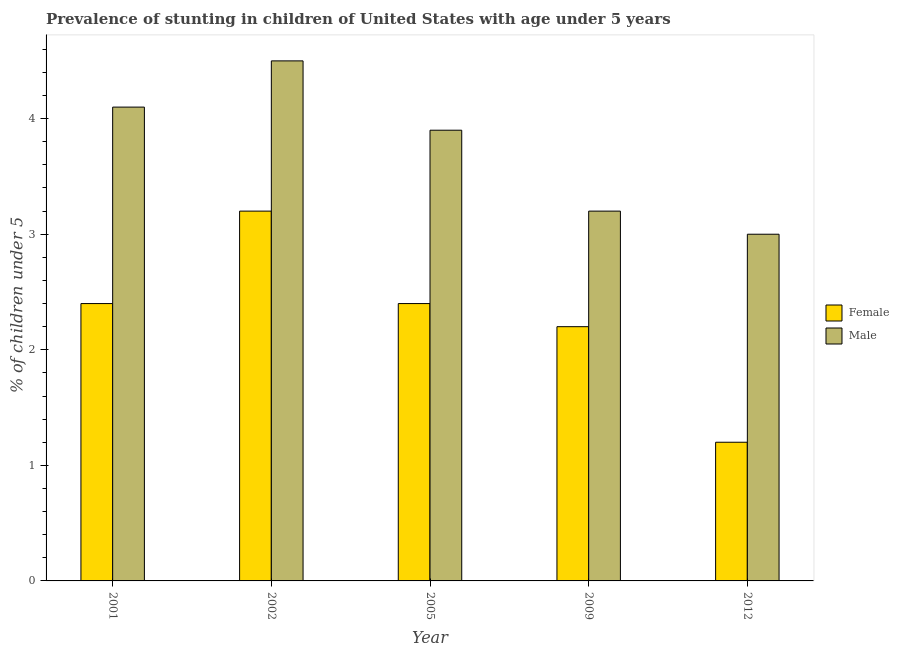Are the number of bars on each tick of the X-axis equal?
Your answer should be compact. Yes. How many bars are there on the 5th tick from the left?
Provide a succinct answer. 2. How many bars are there on the 4th tick from the right?
Your answer should be very brief. 2. What is the label of the 2nd group of bars from the left?
Provide a short and direct response. 2002. In how many cases, is the number of bars for a given year not equal to the number of legend labels?
Provide a short and direct response. 0. What is the percentage of stunted female children in 2009?
Offer a terse response. 2.2. In which year was the percentage of stunted female children maximum?
Offer a terse response. 2002. What is the total percentage of stunted female children in the graph?
Offer a very short reply. 11.4. What is the difference between the percentage of stunted female children in 2009 and that in 2012?
Offer a very short reply. 1. What is the difference between the percentage of stunted male children in 2009 and the percentage of stunted female children in 2012?
Provide a short and direct response. 0.2. What is the average percentage of stunted female children per year?
Your response must be concise. 2.28. In the year 2002, what is the difference between the percentage of stunted female children and percentage of stunted male children?
Keep it short and to the point. 0. What is the ratio of the percentage of stunted female children in 2005 to that in 2012?
Your answer should be compact. 2. Is the difference between the percentage of stunted female children in 2002 and 2005 greater than the difference between the percentage of stunted male children in 2002 and 2005?
Your answer should be compact. No. What is the difference between the highest and the second highest percentage of stunted male children?
Keep it short and to the point. 0.4. What is the difference between the highest and the lowest percentage of stunted male children?
Offer a terse response. 1.5. What does the 2nd bar from the left in 2009 represents?
Offer a terse response. Male. How many bars are there?
Provide a succinct answer. 10. Are all the bars in the graph horizontal?
Provide a succinct answer. No. Does the graph contain any zero values?
Keep it short and to the point. No. How are the legend labels stacked?
Offer a very short reply. Vertical. What is the title of the graph?
Provide a succinct answer. Prevalence of stunting in children of United States with age under 5 years. Does "Constant 2005 US$" appear as one of the legend labels in the graph?
Provide a succinct answer. No. What is the label or title of the X-axis?
Give a very brief answer. Year. What is the label or title of the Y-axis?
Your answer should be very brief.  % of children under 5. What is the  % of children under 5 in Female in 2001?
Your answer should be very brief. 2.4. What is the  % of children under 5 in Male in 2001?
Your answer should be very brief. 4.1. What is the  % of children under 5 of Female in 2002?
Ensure brevity in your answer.  3.2. What is the  % of children under 5 of Male in 2002?
Your answer should be compact. 4.5. What is the  % of children under 5 of Female in 2005?
Keep it short and to the point. 2.4. What is the  % of children under 5 in Male in 2005?
Ensure brevity in your answer.  3.9. What is the  % of children under 5 of Female in 2009?
Offer a very short reply. 2.2. What is the  % of children under 5 of Male in 2009?
Keep it short and to the point. 3.2. What is the  % of children under 5 of Female in 2012?
Ensure brevity in your answer.  1.2. Across all years, what is the maximum  % of children under 5 of Female?
Keep it short and to the point. 3.2. Across all years, what is the maximum  % of children under 5 of Male?
Provide a succinct answer. 4.5. Across all years, what is the minimum  % of children under 5 of Female?
Keep it short and to the point. 1.2. Across all years, what is the minimum  % of children under 5 of Male?
Your answer should be compact. 3. What is the total  % of children under 5 of Female in the graph?
Your response must be concise. 11.4. What is the total  % of children under 5 of Male in the graph?
Your response must be concise. 18.7. What is the difference between the  % of children under 5 of Female in 2001 and that in 2002?
Keep it short and to the point. -0.8. What is the difference between the  % of children under 5 in Male in 2001 and that in 2002?
Give a very brief answer. -0.4. What is the difference between the  % of children under 5 in Female in 2001 and that in 2005?
Provide a short and direct response. 0. What is the difference between the  % of children under 5 in Male in 2001 and that in 2005?
Ensure brevity in your answer.  0.2. What is the difference between the  % of children under 5 in Female in 2001 and that in 2012?
Keep it short and to the point. 1.2. What is the difference between the  % of children under 5 in Female in 2002 and that in 2005?
Offer a very short reply. 0.8. What is the difference between the  % of children under 5 of Female in 2005 and that in 2009?
Your answer should be very brief. 0.2. What is the difference between the  % of children under 5 of Male in 2005 and that in 2009?
Make the answer very short. 0.7. What is the difference between the  % of children under 5 in Female in 2005 and that in 2012?
Give a very brief answer. 1.2. What is the difference between the  % of children under 5 of Male in 2009 and that in 2012?
Provide a succinct answer. 0.2. What is the difference between the  % of children under 5 in Female in 2001 and the  % of children under 5 in Male in 2002?
Provide a succinct answer. -2.1. What is the difference between the  % of children under 5 of Female in 2001 and the  % of children under 5 of Male in 2005?
Ensure brevity in your answer.  -1.5. What is the difference between the  % of children under 5 in Female in 2001 and the  % of children under 5 in Male in 2012?
Your answer should be compact. -0.6. What is the difference between the  % of children under 5 in Female in 2002 and the  % of children under 5 in Male in 2009?
Offer a very short reply. 0. What is the difference between the  % of children under 5 of Female in 2009 and the  % of children under 5 of Male in 2012?
Your answer should be very brief. -0.8. What is the average  % of children under 5 in Female per year?
Provide a short and direct response. 2.28. What is the average  % of children under 5 of Male per year?
Ensure brevity in your answer.  3.74. In the year 2001, what is the difference between the  % of children under 5 of Female and  % of children under 5 of Male?
Your answer should be compact. -1.7. In the year 2002, what is the difference between the  % of children under 5 of Female and  % of children under 5 of Male?
Ensure brevity in your answer.  -1.3. In the year 2005, what is the difference between the  % of children under 5 of Female and  % of children under 5 of Male?
Offer a terse response. -1.5. What is the ratio of the  % of children under 5 in Male in 2001 to that in 2002?
Your answer should be compact. 0.91. What is the ratio of the  % of children under 5 of Male in 2001 to that in 2005?
Make the answer very short. 1.05. What is the ratio of the  % of children under 5 in Female in 2001 to that in 2009?
Give a very brief answer. 1.09. What is the ratio of the  % of children under 5 of Male in 2001 to that in 2009?
Provide a short and direct response. 1.28. What is the ratio of the  % of children under 5 in Female in 2001 to that in 2012?
Offer a very short reply. 2. What is the ratio of the  % of children under 5 of Male in 2001 to that in 2012?
Your answer should be compact. 1.37. What is the ratio of the  % of children under 5 in Female in 2002 to that in 2005?
Ensure brevity in your answer.  1.33. What is the ratio of the  % of children under 5 of Male in 2002 to that in 2005?
Provide a short and direct response. 1.15. What is the ratio of the  % of children under 5 in Female in 2002 to that in 2009?
Your answer should be compact. 1.45. What is the ratio of the  % of children under 5 in Male in 2002 to that in 2009?
Offer a terse response. 1.41. What is the ratio of the  % of children under 5 in Female in 2002 to that in 2012?
Ensure brevity in your answer.  2.67. What is the ratio of the  % of children under 5 in Male in 2002 to that in 2012?
Ensure brevity in your answer.  1.5. What is the ratio of the  % of children under 5 in Female in 2005 to that in 2009?
Your response must be concise. 1.09. What is the ratio of the  % of children under 5 of Male in 2005 to that in 2009?
Make the answer very short. 1.22. What is the ratio of the  % of children under 5 of Female in 2009 to that in 2012?
Offer a very short reply. 1.83. What is the ratio of the  % of children under 5 in Male in 2009 to that in 2012?
Provide a short and direct response. 1.07. What is the difference between the highest and the lowest  % of children under 5 of Female?
Your response must be concise. 2. 